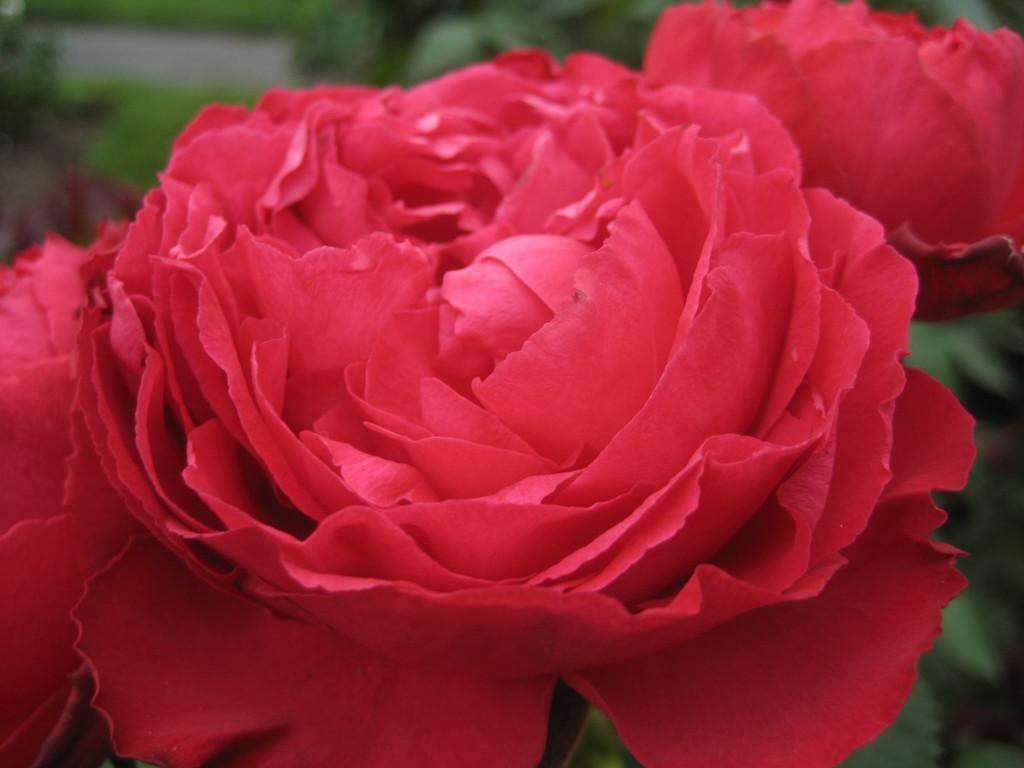How would you summarize this image in a sentence or two? In this image there are two rose flowers behind them there are so many plants. 